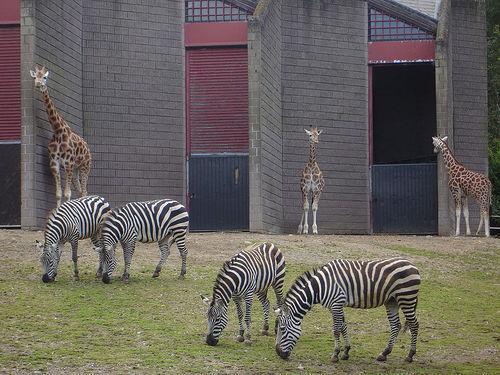How many animals are in the photo?
Give a very brief answer. 7. 